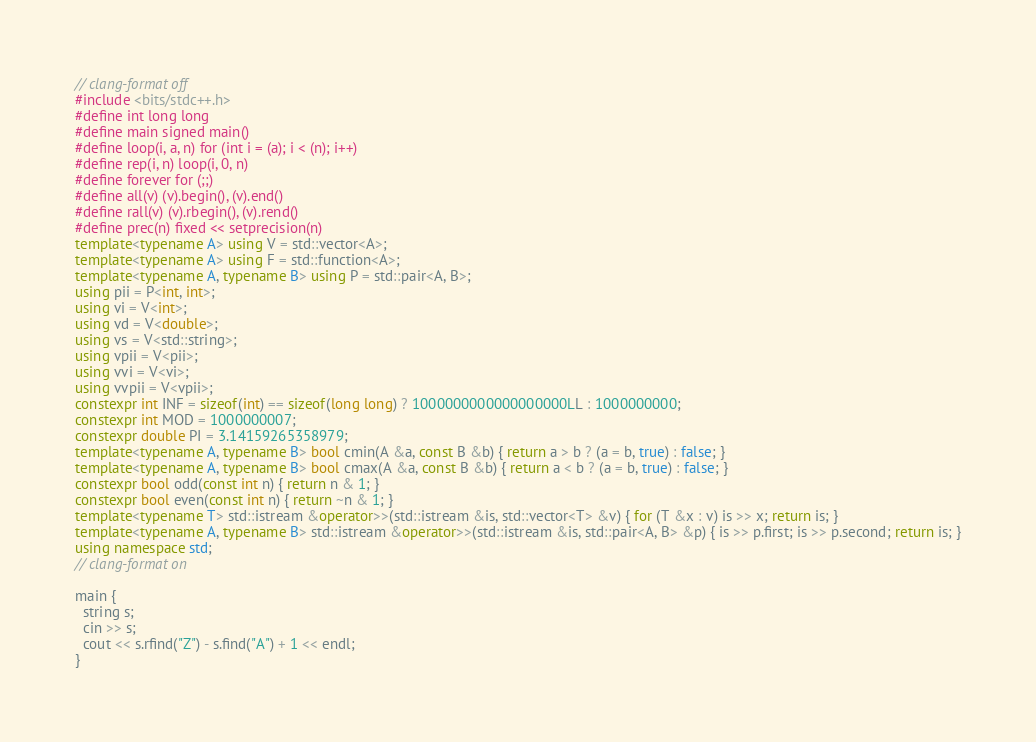Convert code to text. <code><loc_0><loc_0><loc_500><loc_500><_C++_>// clang-format off
#include <bits/stdc++.h>
#define int long long
#define main signed main()
#define loop(i, a, n) for (int i = (a); i < (n); i++)
#define rep(i, n) loop(i, 0, n)
#define forever for (;;)
#define all(v) (v).begin(), (v).end()
#define rall(v) (v).rbegin(), (v).rend()
#define prec(n) fixed << setprecision(n)
template<typename A> using V = std::vector<A>;
template<typename A> using F = std::function<A>;
template<typename A, typename B> using P = std::pair<A, B>;
using pii = P<int, int>;
using vi = V<int>;
using vd = V<double>;
using vs = V<std::string>;
using vpii = V<pii>;
using vvi = V<vi>;
using vvpii = V<vpii>;
constexpr int INF = sizeof(int) == sizeof(long long) ? 1000000000000000000LL : 1000000000;
constexpr int MOD = 1000000007;
constexpr double PI = 3.14159265358979;
template<typename A, typename B> bool cmin(A &a, const B &b) { return a > b ? (a = b, true) : false; }
template<typename A, typename B> bool cmax(A &a, const B &b) { return a < b ? (a = b, true) : false; }
constexpr bool odd(const int n) { return n & 1; }
constexpr bool even(const int n) { return ~n & 1; }
template<typename T> std::istream &operator>>(std::istream &is, std::vector<T> &v) { for (T &x : v) is >> x; return is; }
template<typename A, typename B> std::istream &operator>>(std::istream &is, std::pair<A, B> &p) { is >> p.first; is >> p.second; return is; }
using namespace std;
// clang-format on

main {
  string s;
  cin >> s;
  cout << s.rfind("Z") - s.find("A") + 1 << endl;
}
</code> 